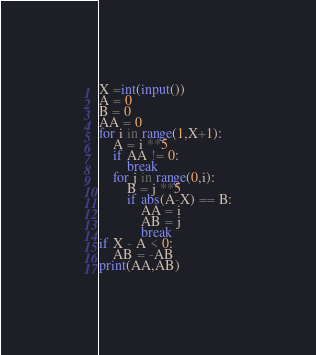<code> <loc_0><loc_0><loc_500><loc_500><_Python_>X =int(input())
A = 0
B = 0
AA = 0
for i in range(1,X+1):
    A = i **5
    if AA != 0:
        break
    for j in range(0,i):
        B = j **5
        if abs(A-X) == B:
            AA = i
            AB = j
            break
if X - A < 0:
    AB = -AB
print(AA,AB)</code> 